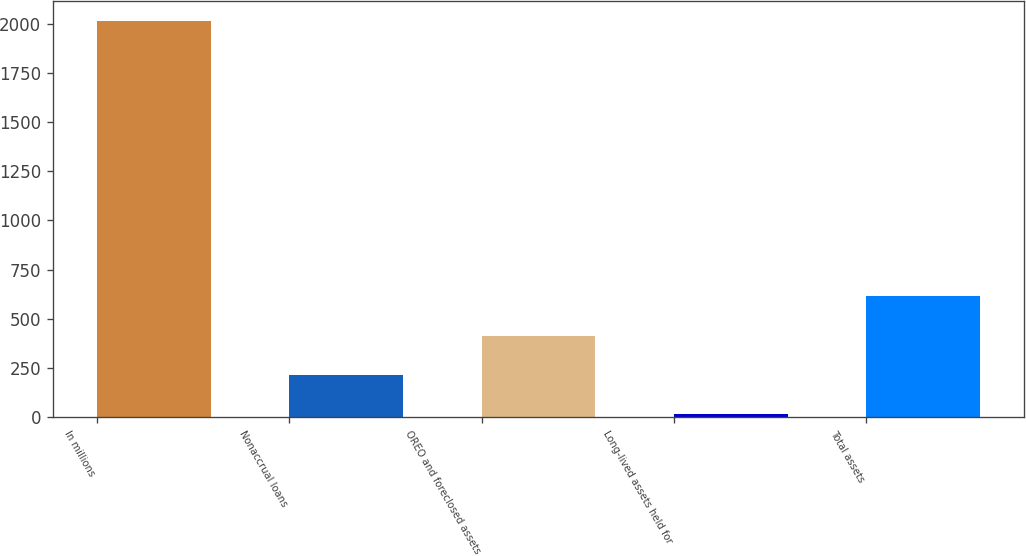<chart> <loc_0><loc_0><loc_500><loc_500><bar_chart><fcel>In millions<fcel>Nonaccrual loans<fcel>OREO and foreclosed assets<fcel>Long-lived assets held for<fcel>Total assets<nl><fcel>2014<fcel>214<fcel>414<fcel>14<fcel>614<nl></chart> 